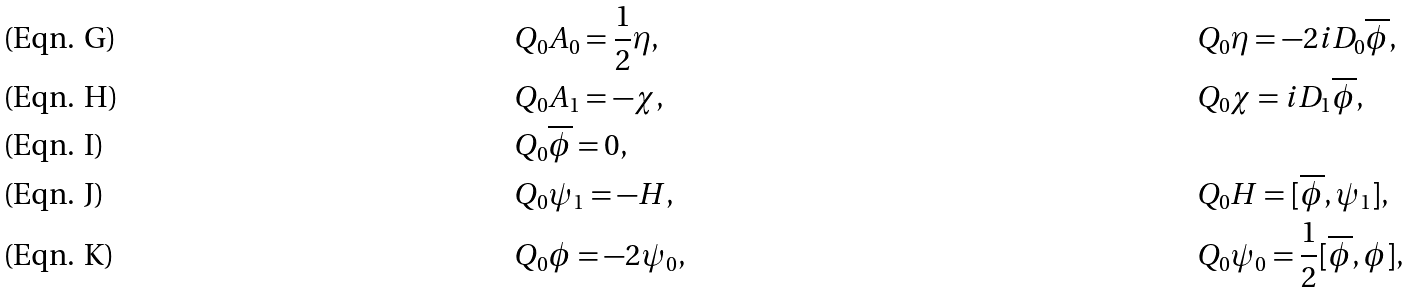Convert formula to latex. <formula><loc_0><loc_0><loc_500><loc_500>& Q _ { 0 } A _ { 0 } = \frac { 1 } { 2 } \eta , & & Q _ { 0 } \eta = - 2 i D _ { 0 } \overline { \phi } , \\ & Q _ { 0 } A _ { 1 } = - \chi , & & Q _ { 0 } \chi = i D _ { 1 } \overline { \phi } , \\ & Q _ { 0 } \overline { \phi } = 0 , & & \\ & Q _ { 0 } \psi _ { 1 } = - H , & & Q _ { 0 } H = [ \overline { \phi } , \psi _ { 1 } ] , \\ & Q _ { 0 } \phi = - 2 \psi _ { 0 } , & & Q _ { 0 } \psi _ { 0 } = \frac { 1 } { 2 } [ \overline { \phi } , \phi ] ,</formula> 